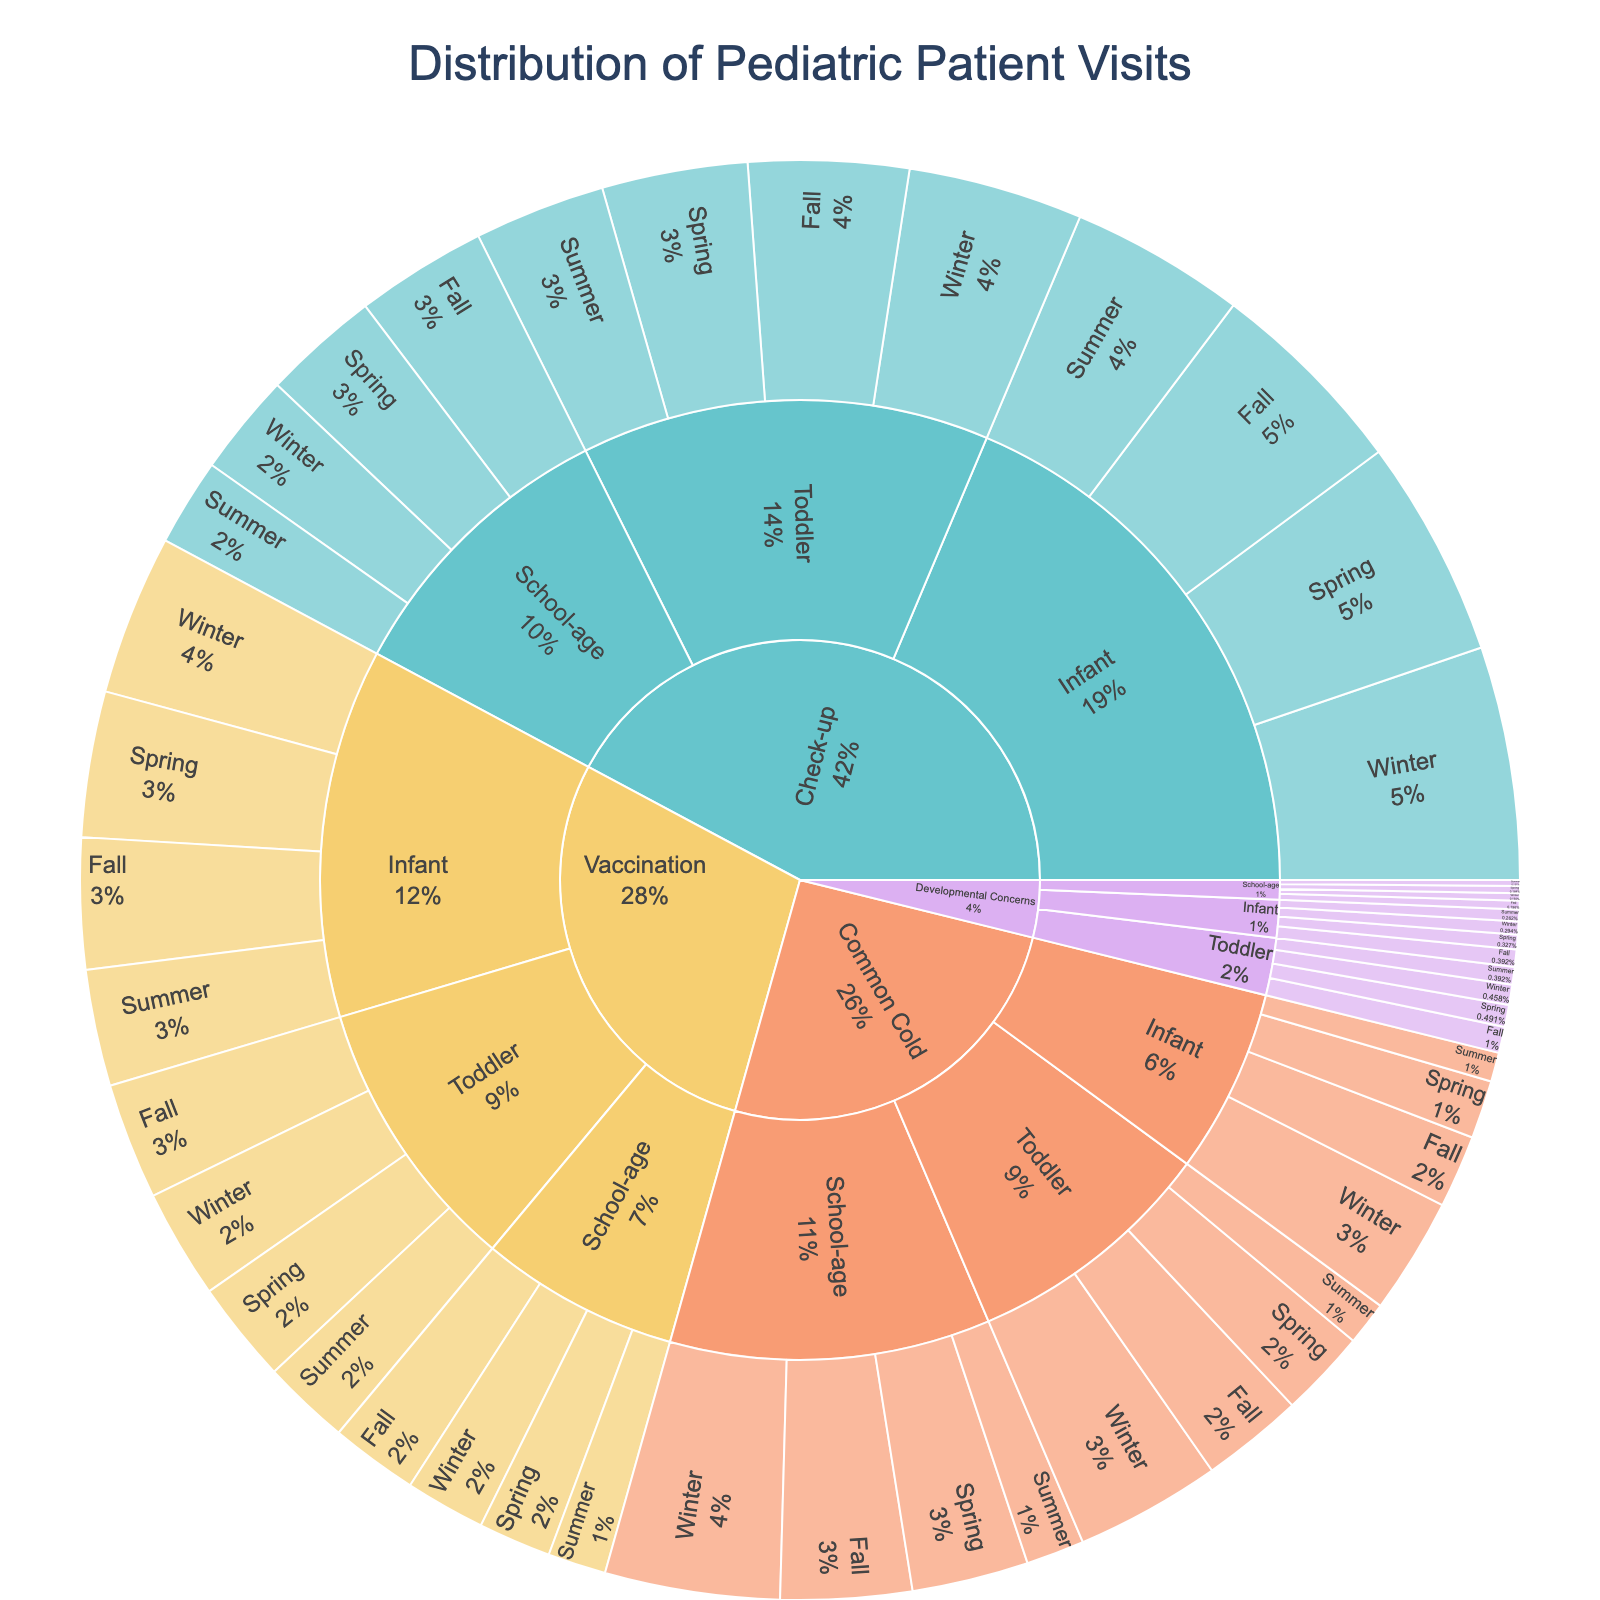What is the title of the figure? The title of the figure is located at the top, centered and typically in a larger font size. It summarizes the content of the plot.
Answer: Distribution of Pediatric Patient Visits Which reason for visits has the highest overall value for the Infant age group across all seasons? To answer this, look at the total values for each reason within the Infant age group. The largest combined value across Spring, Summer, Fall, and Winter will be the answer.
Answer: Check-up During which season do School-age children visit for vaccinations the most? Locate the School-age group, then focus on the Vaccination segment. From there, compare the values for each season to identify the highest.
Answer: Fall What is the combined value of Check-up visits for the Toddler age group in Spring and Winter? First, find the Check-up segment for the Toddler age group and locate the values for Spring and Winter. Add those two values together (100 + 120).
Answer: 220 Which segment has the lowest percentage of visits overall? In a sunburst plot, the segments with the smallest areas or size will contain the lowest percentage of visits. Look for the smallest visual segment when considering the entire plot.
Answer: Developmental Concerns, School-age, Summer How does the number of common cold visits for Infants in Winter compare to that for Toddlers in Winter? Check the specific sections for the Infants and Toddlers age groups under the Common Cold reason in the Winter season. Compare the values visually or hover over to read the exact numbers.
Answer: Infants (80) < Toddlers (100) For School-age children, which reason for visit has the closest total value between Spring and Fall seasons? Examine the School-age group for each reason's segment; then, look at the Spring and Fall seasons' values for each. Find which reason has the closest values between these seasons (e.g., (80 - 90) for Check-up, compare differences for other segments).
Answer: Common Cold (80 in Spring, 90 in Fall) How many visits were recorded for Infant vaccinations in both Summer and Fall combined? Find the Vaccination segment for the Infant age group, then locate the Summer and Fall seasons’ values. Add these two values (80 + 90).
Answer: 170 